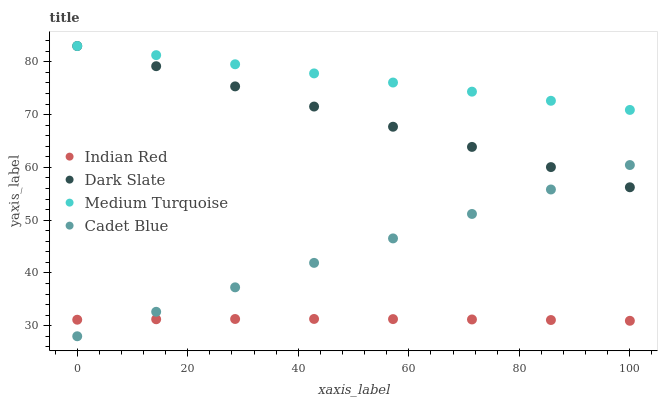Does Indian Red have the minimum area under the curve?
Answer yes or no. Yes. Does Medium Turquoise have the maximum area under the curve?
Answer yes or no. Yes. Does Cadet Blue have the minimum area under the curve?
Answer yes or no. No. Does Cadet Blue have the maximum area under the curve?
Answer yes or no. No. Is Medium Turquoise the smoothest?
Answer yes or no. Yes. Is Indian Red the roughest?
Answer yes or no. Yes. Is Cadet Blue the smoothest?
Answer yes or no. No. Is Cadet Blue the roughest?
Answer yes or no. No. Does Cadet Blue have the lowest value?
Answer yes or no. Yes. Does Medium Turquoise have the lowest value?
Answer yes or no. No. Does Medium Turquoise have the highest value?
Answer yes or no. Yes. Does Cadet Blue have the highest value?
Answer yes or no. No. Is Indian Red less than Dark Slate?
Answer yes or no. Yes. Is Dark Slate greater than Indian Red?
Answer yes or no. Yes. Does Cadet Blue intersect Dark Slate?
Answer yes or no. Yes. Is Cadet Blue less than Dark Slate?
Answer yes or no. No. Is Cadet Blue greater than Dark Slate?
Answer yes or no. No. Does Indian Red intersect Dark Slate?
Answer yes or no. No. 